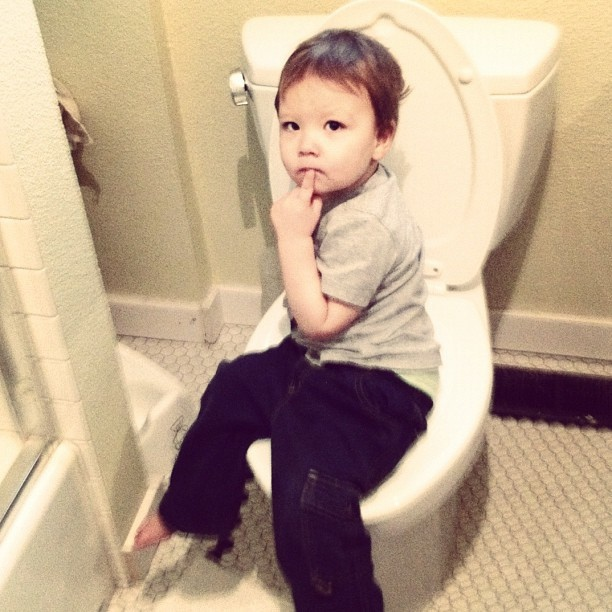Describe the objects in this image and their specific colors. I can see toilet in beige, navy, and tan tones and people in beige, navy, tan, and brown tones in this image. 